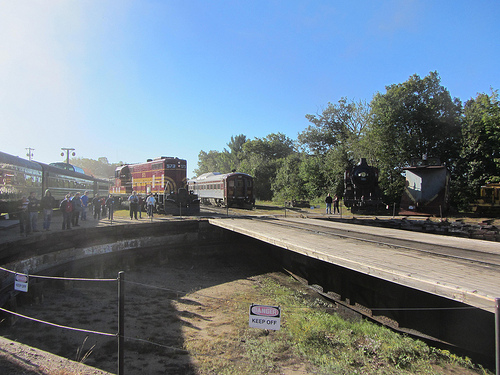The leaves are on what? The leaves are on trees in the background of the image. 